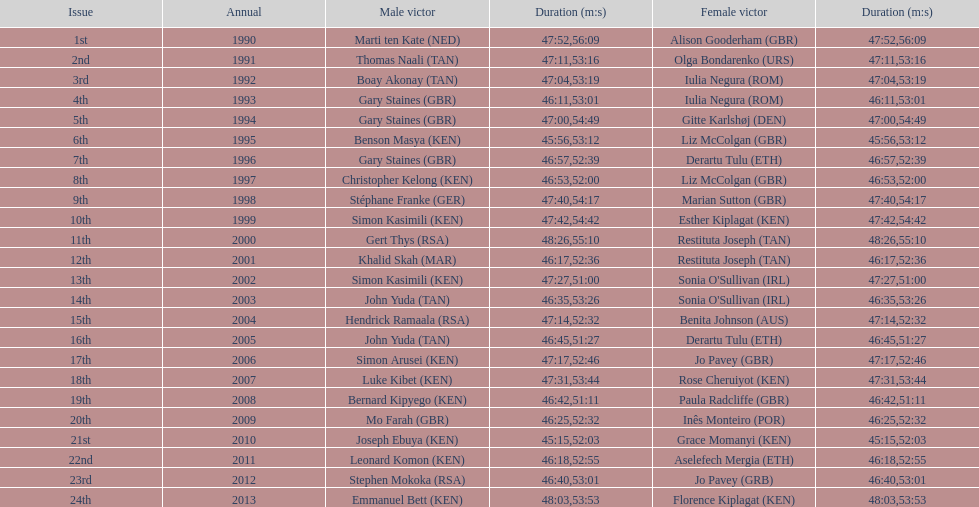Number of men's winners with a finish time under 46:58 12. 